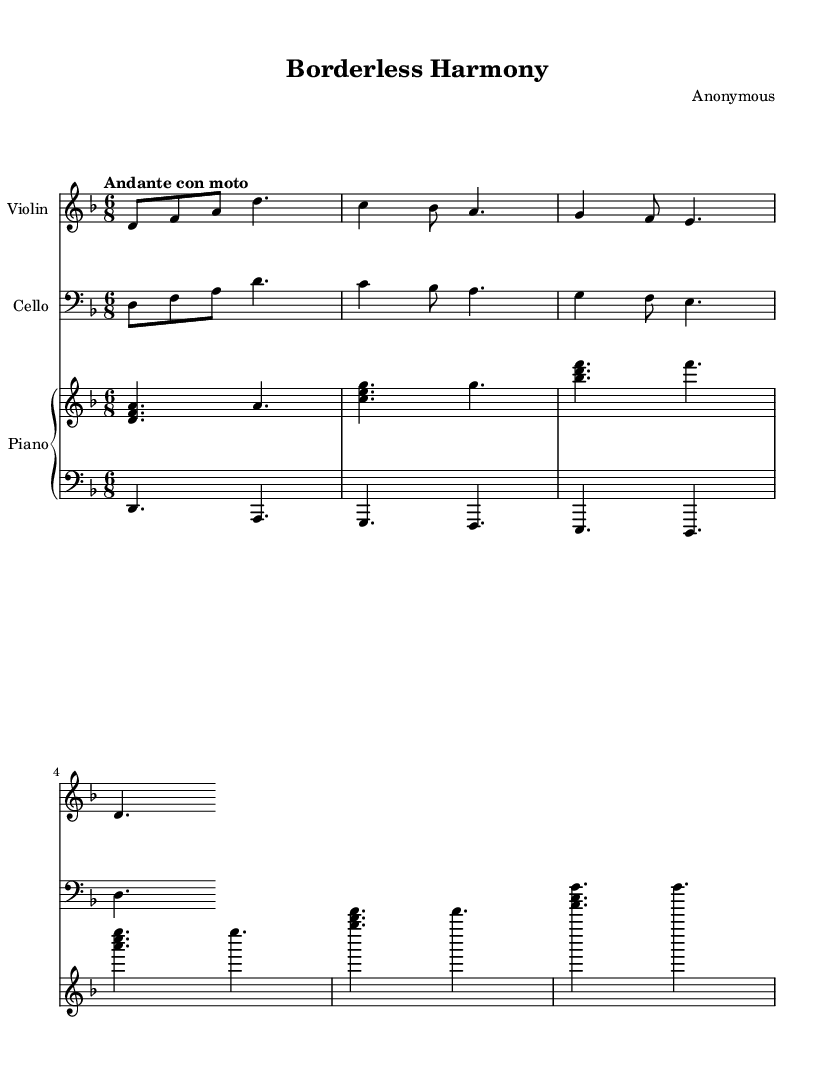What is the key signature of this music? The key signature is D minor, which has one flat (B flat). It can be identified by looking at the key signature at the beginning of the staff.
Answer: D minor What is the time signature of this music? The time signature is 6/8, which can be seen at the beginning of the piece, indicating it has 6 eighth notes per measure.
Answer: 6/8 What is the tempo indication for this piece? The tempo indication is "Andante con moto," which translates to a moderate pace with some motion. This can be found written above the staff.
Answer: Andante con moto How many measures are in the violin part? The violin part contains 4 measures, which can be counted by viewing the vertical lines (bar lines) that separate each measure in that staff.
Answer: 4 Which instruments are included in this composition? The composition includes violin, cello, and piano, as can be seen in the instrument names written above each respective staff.
Answer: Violin, cello, piano What is the dynamic marking for the first measure? The first measure has no dynamic marking, indicating it should be played at a normal volume. This can be deduced by examining the absence of dynamic symbols in that measure.
Answer: None 